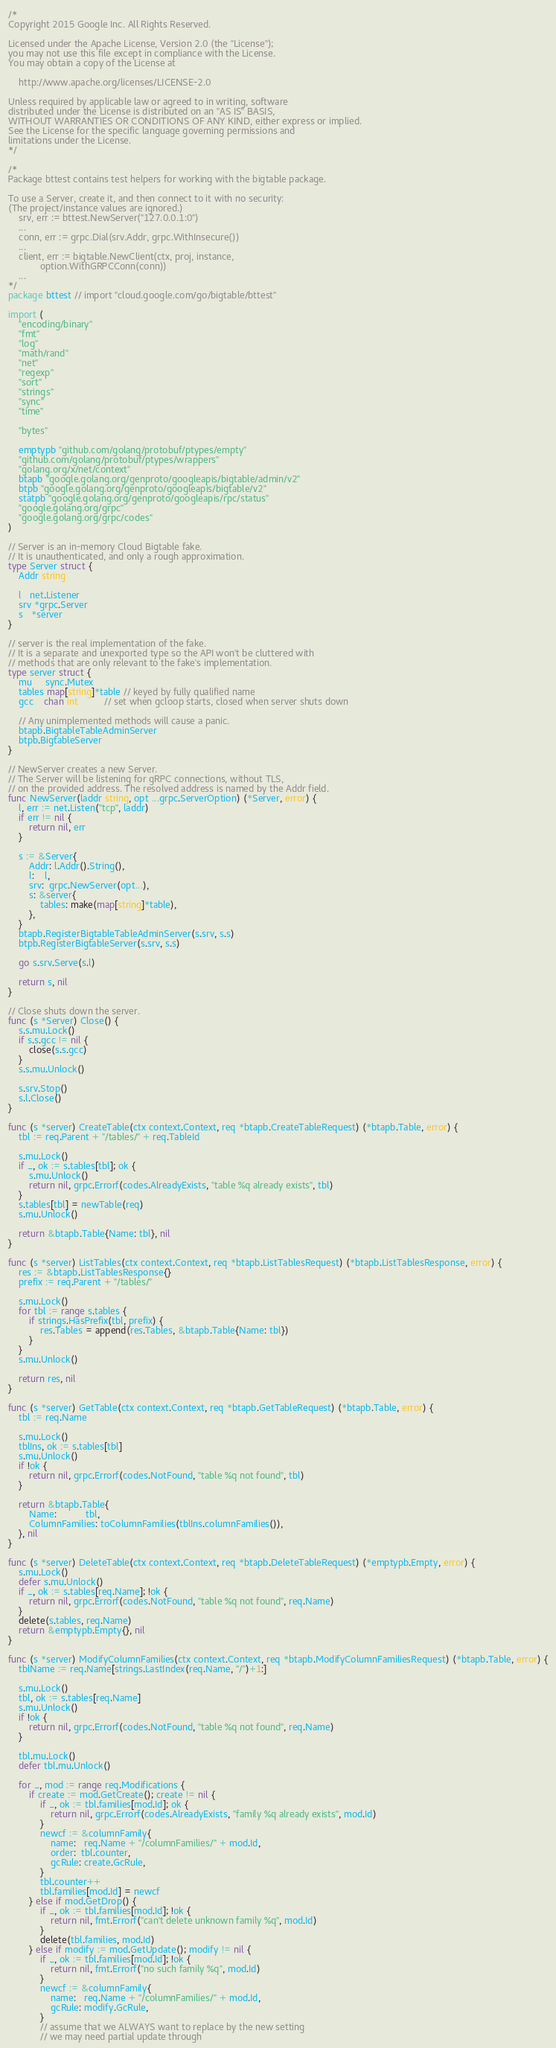<code> <loc_0><loc_0><loc_500><loc_500><_Go_>/*
Copyright 2015 Google Inc. All Rights Reserved.

Licensed under the Apache License, Version 2.0 (the "License");
you may not use this file except in compliance with the License.
You may obtain a copy of the License at

    http://www.apache.org/licenses/LICENSE-2.0

Unless required by applicable law or agreed to in writing, software
distributed under the License is distributed on an "AS IS" BASIS,
WITHOUT WARRANTIES OR CONDITIONS OF ANY KIND, either express or implied.
See the License for the specific language governing permissions and
limitations under the License.
*/

/*
Package bttest contains test helpers for working with the bigtable package.

To use a Server, create it, and then connect to it with no security:
(The project/instance values are ignored.)
	srv, err := bttest.NewServer("127.0.0.1:0")
	...
	conn, err := grpc.Dial(srv.Addr, grpc.WithInsecure())
	...
	client, err := bigtable.NewClient(ctx, proj, instance,
	        option.WithGRPCConn(conn))
	...
*/
package bttest // import "cloud.google.com/go/bigtable/bttest"

import (
	"encoding/binary"
	"fmt"
	"log"
	"math/rand"
	"net"
	"regexp"
	"sort"
	"strings"
	"sync"
	"time"

	"bytes"

	emptypb "github.com/golang/protobuf/ptypes/empty"
	"github.com/golang/protobuf/ptypes/wrappers"
	"golang.org/x/net/context"
	btapb "google.golang.org/genproto/googleapis/bigtable/admin/v2"
	btpb "google.golang.org/genproto/googleapis/bigtable/v2"
	statpb "google.golang.org/genproto/googleapis/rpc/status"
	"google.golang.org/grpc"
	"google.golang.org/grpc/codes"
)

// Server is an in-memory Cloud Bigtable fake.
// It is unauthenticated, and only a rough approximation.
type Server struct {
	Addr string

	l   net.Listener
	srv *grpc.Server
	s   *server
}

// server is the real implementation of the fake.
// It is a separate and unexported type so the API won't be cluttered with
// methods that are only relevant to the fake's implementation.
type server struct {
	mu     sync.Mutex
	tables map[string]*table // keyed by fully qualified name
	gcc    chan int          // set when gcloop starts, closed when server shuts down

	// Any unimplemented methods will cause a panic.
	btapb.BigtableTableAdminServer
	btpb.BigtableServer
}

// NewServer creates a new Server.
// The Server will be listening for gRPC connections, without TLS,
// on the provided address. The resolved address is named by the Addr field.
func NewServer(laddr string, opt ...grpc.ServerOption) (*Server, error) {
	l, err := net.Listen("tcp", laddr)
	if err != nil {
		return nil, err
	}

	s := &Server{
		Addr: l.Addr().String(),
		l:    l,
		srv:  grpc.NewServer(opt...),
		s: &server{
			tables: make(map[string]*table),
		},
	}
	btapb.RegisterBigtableTableAdminServer(s.srv, s.s)
	btpb.RegisterBigtableServer(s.srv, s.s)

	go s.srv.Serve(s.l)

	return s, nil
}

// Close shuts down the server.
func (s *Server) Close() {
	s.s.mu.Lock()
	if s.s.gcc != nil {
		close(s.s.gcc)
	}
	s.s.mu.Unlock()

	s.srv.Stop()
	s.l.Close()
}

func (s *server) CreateTable(ctx context.Context, req *btapb.CreateTableRequest) (*btapb.Table, error) {
	tbl := req.Parent + "/tables/" + req.TableId

	s.mu.Lock()
	if _, ok := s.tables[tbl]; ok {
		s.mu.Unlock()
		return nil, grpc.Errorf(codes.AlreadyExists, "table %q already exists", tbl)
	}
	s.tables[tbl] = newTable(req)
	s.mu.Unlock()

	return &btapb.Table{Name: tbl}, nil
}

func (s *server) ListTables(ctx context.Context, req *btapb.ListTablesRequest) (*btapb.ListTablesResponse, error) {
	res := &btapb.ListTablesResponse{}
	prefix := req.Parent + "/tables/"

	s.mu.Lock()
	for tbl := range s.tables {
		if strings.HasPrefix(tbl, prefix) {
			res.Tables = append(res.Tables, &btapb.Table{Name: tbl})
		}
	}
	s.mu.Unlock()

	return res, nil
}

func (s *server) GetTable(ctx context.Context, req *btapb.GetTableRequest) (*btapb.Table, error) {
	tbl := req.Name

	s.mu.Lock()
	tblIns, ok := s.tables[tbl]
	s.mu.Unlock()
	if !ok {
		return nil, grpc.Errorf(codes.NotFound, "table %q not found", tbl)
	}

	return &btapb.Table{
		Name:           tbl,
		ColumnFamilies: toColumnFamilies(tblIns.columnFamilies()),
	}, nil
}

func (s *server) DeleteTable(ctx context.Context, req *btapb.DeleteTableRequest) (*emptypb.Empty, error) {
	s.mu.Lock()
	defer s.mu.Unlock()
	if _, ok := s.tables[req.Name]; !ok {
		return nil, grpc.Errorf(codes.NotFound, "table %q not found", req.Name)
	}
	delete(s.tables, req.Name)
	return &emptypb.Empty{}, nil
}

func (s *server) ModifyColumnFamilies(ctx context.Context, req *btapb.ModifyColumnFamiliesRequest) (*btapb.Table, error) {
	tblName := req.Name[strings.LastIndex(req.Name, "/")+1:]

	s.mu.Lock()
	tbl, ok := s.tables[req.Name]
	s.mu.Unlock()
	if !ok {
		return nil, grpc.Errorf(codes.NotFound, "table %q not found", req.Name)
	}

	tbl.mu.Lock()
	defer tbl.mu.Unlock()

	for _, mod := range req.Modifications {
		if create := mod.GetCreate(); create != nil {
			if _, ok := tbl.families[mod.Id]; ok {
				return nil, grpc.Errorf(codes.AlreadyExists, "family %q already exists", mod.Id)
			}
			newcf := &columnFamily{
				name:   req.Name + "/columnFamilies/" + mod.Id,
				order:  tbl.counter,
				gcRule: create.GcRule,
			}
			tbl.counter++
			tbl.families[mod.Id] = newcf
		} else if mod.GetDrop() {
			if _, ok := tbl.families[mod.Id]; !ok {
				return nil, fmt.Errorf("can't delete unknown family %q", mod.Id)
			}
			delete(tbl.families, mod.Id)
		} else if modify := mod.GetUpdate(); modify != nil {
			if _, ok := tbl.families[mod.Id]; !ok {
				return nil, fmt.Errorf("no such family %q", mod.Id)
			}
			newcf := &columnFamily{
				name:   req.Name + "/columnFamilies/" + mod.Id,
				gcRule: modify.GcRule,
			}
			// assume that we ALWAYS want to replace by the new setting
			// we may need partial update through</code> 